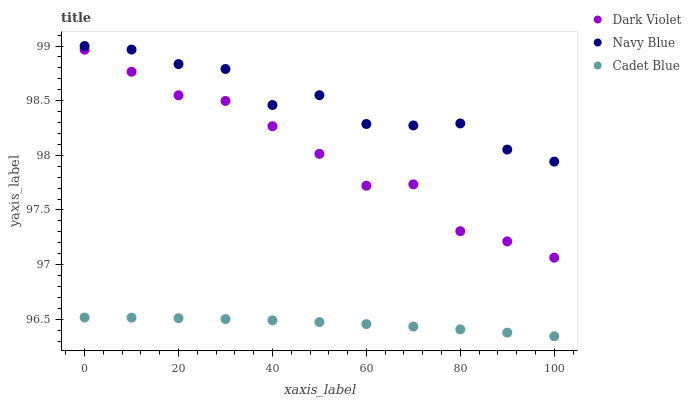Does Cadet Blue have the minimum area under the curve?
Answer yes or no. Yes. Does Navy Blue have the maximum area under the curve?
Answer yes or no. Yes. Does Dark Violet have the minimum area under the curve?
Answer yes or no. No. Does Dark Violet have the maximum area under the curve?
Answer yes or no. No. Is Cadet Blue the smoothest?
Answer yes or no. Yes. Is Navy Blue the roughest?
Answer yes or no. Yes. Is Dark Violet the smoothest?
Answer yes or no. No. Is Dark Violet the roughest?
Answer yes or no. No. Does Cadet Blue have the lowest value?
Answer yes or no. Yes. Does Dark Violet have the lowest value?
Answer yes or no. No. Does Navy Blue have the highest value?
Answer yes or no. Yes. Does Dark Violet have the highest value?
Answer yes or no. No. Is Cadet Blue less than Dark Violet?
Answer yes or no. Yes. Is Navy Blue greater than Dark Violet?
Answer yes or no. Yes. Does Cadet Blue intersect Dark Violet?
Answer yes or no. No. 